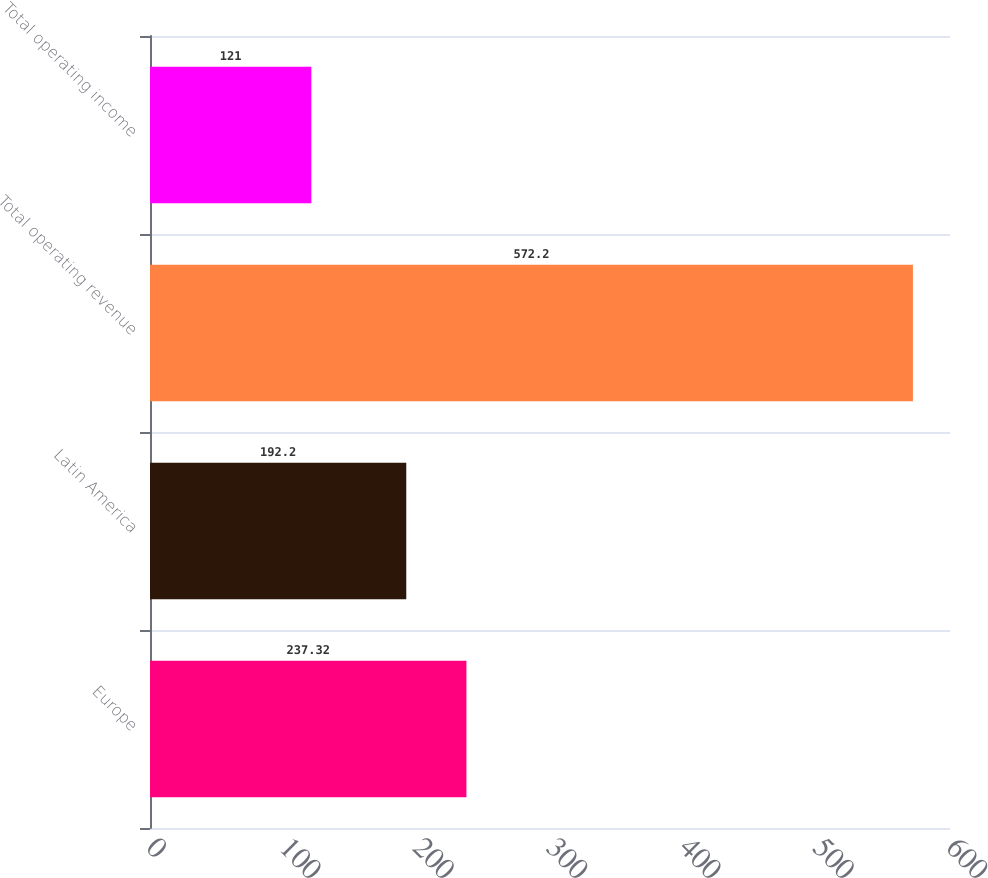Convert chart. <chart><loc_0><loc_0><loc_500><loc_500><bar_chart><fcel>Europe<fcel>Latin America<fcel>Total operating revenue<fcel>Total operating income<nl><fcel>237.32<fcel>192.2<fcel>572.2<fcel>121<nl></chart> 